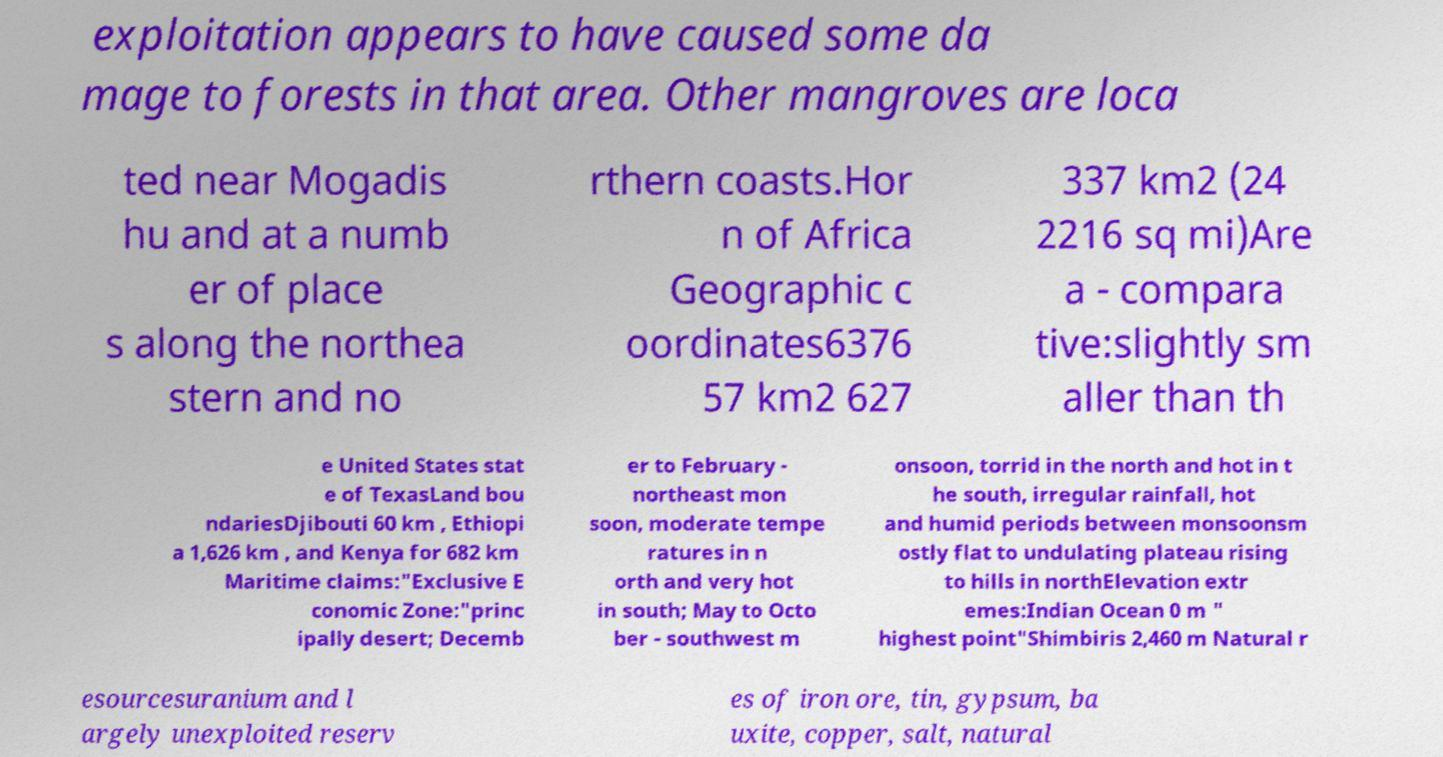What messages or text are displayed in this image? I need them in a readable, typed format. exploitation appears to have caused some da mage to forests in that area. Other mangroves are loca ted near Mogadis hu and at a numb er of place s along the northea stern and no rthern coasts.Hor n of Africa Geographic c oordinates6376 57 km2 627 337 km2 (24 2216 sq mi)Are a - compara tive:slightly sm aller than th e United States stat e of TexasLand bou ndariesDjibouti 60 km , Ethiopi a 1,626 km , and Kenya for 682 km Maritime claims:"Exclusive E conomic Zone:"princ ipally desert; Decemb er to February - northeast mon soon, moderate tempe ratures in n orth and very hot in south; May to Octo ber - southwest m onsoon, torrid in the north and hot in t he south, irregular rainfall, hot and humid periods between monsoonsm ostly flat to undulating plateau rising to hills in northElevation extr emes:Indian Ocean 0 m " highest point"Shimbiris 2,460 m Natural r esourcesuranium and l argely unexploited reserv es of iron ore, tin, gypsum, ba uxite, copper, salt, natural 